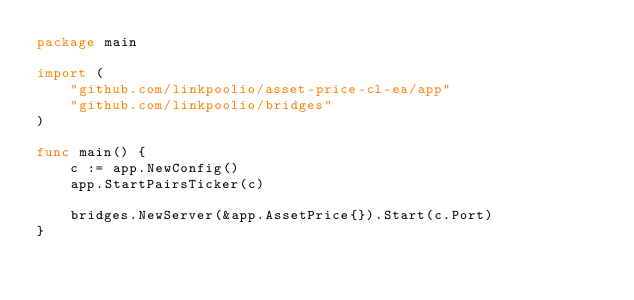Convert code to text. <code><loc_0><loc_0><loc_500><loc_500><_Go_>package main

import (
	"github.com/linkpoolio/asset-price-cl-ea/app"
	"github.com/linkpoolio/bridges"
)

func main() {
	c := app.NewConfig()
	app.StartPairsTicker(c)

	bridges.NewServer(&app.AssetPrice{}).Start(c.Port)
}
</code> 